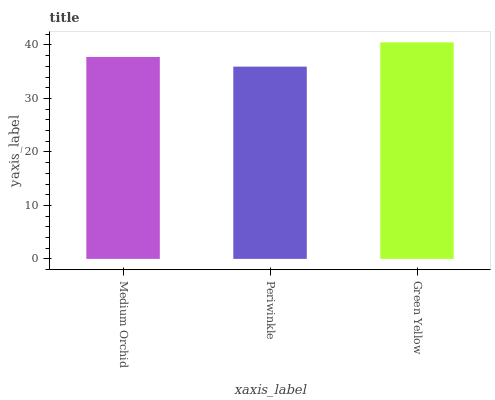Is Periwinkle the minimum?
Answer yes or no. Yes. Is Green Yellow the maximum?
Answer yes or no. Yes. Is Green Yellow the minimum?
Answer yes or no. No. Is Periwinkle the maximum?
Answer yes or no. No. Is Green Yellow greater than Periwinkle?
Answer yes or no. Yes. Is Periwinkle less than Green Yellow?
Answer yes or no. Yes. Is Periwinkle greater than Green Yellow?
Answer yes or no. No. Is Green Yellow less than Periwinkle?
Answer yes or no. No. Is Medium Orchid the high median?
Answer yes or no. Yes. Is Medium Orchid the low median?
Answer yes or no. Yes. Is Periwinkle the high median?
Answer yes or no. No. Is Periwinkle the low median?
Answer yes or no. No. 